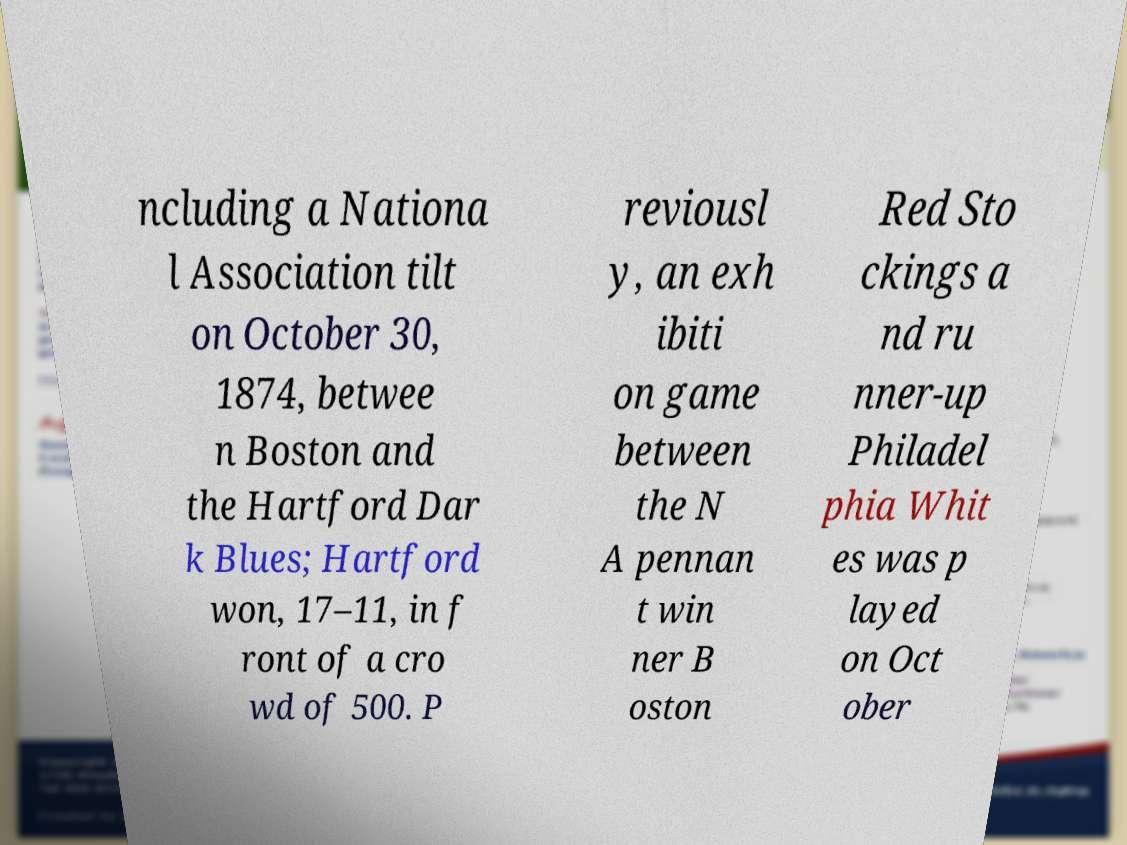Can you read and provide the text displayed in the image?This photo seems to have some interesting text. Can you extract and type it out for me? ncluding a Nationa l Association tilt on October 30, 1874, betwee n Boston and the Hartford Dar k Blues; Hartford won, 17–11, in f ront of a cro wd of 500. P reviousl y, an exh ibiti on game between the N A pennan t win ner B oston Red Sto ckings a nd ru nner-up Philadel phia Whit es was p layed on Oct ober 